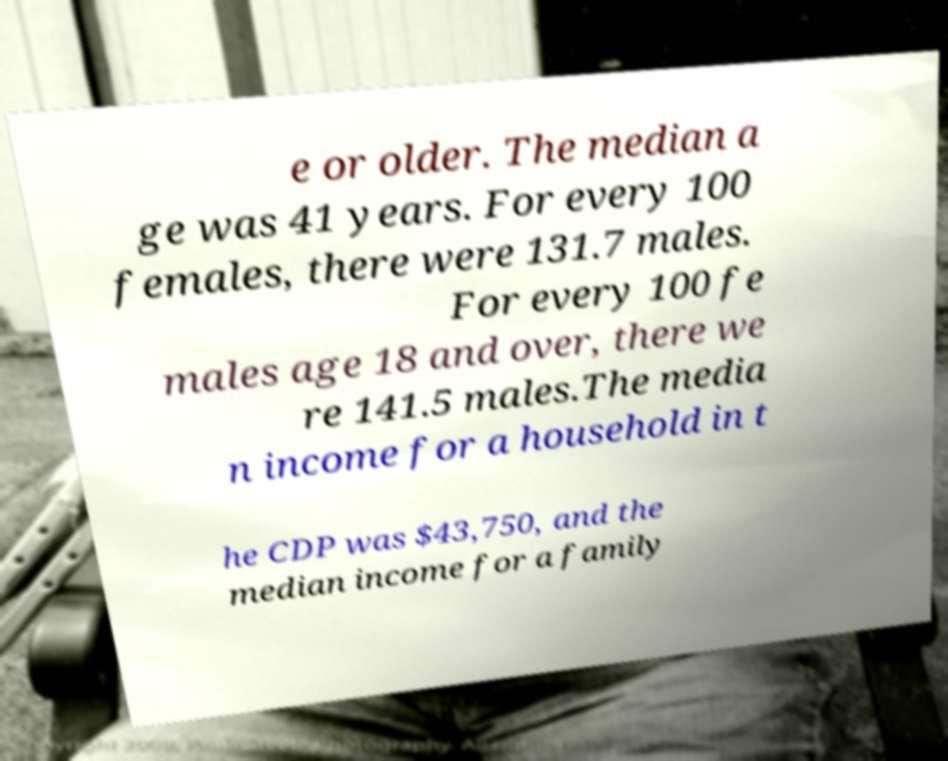Can you read and provide the text displayed in the image?This photo seems to have some interesting text. Can you extract and type it out for me? e or older. The median a ge was 41 years. For every 100 females, there were 131.7 males. For every 100 fe males age 18 and over, there we re 141.5 males.The media n income for a household in t he CDP was $43,750, and the median income for a family 